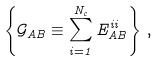<formula> <loc_0><loc_0><loc_500><loc_500>\left \{ \mathcal { G } _ { A B } \equiv \sum _ { i = 1 } ^ { N _ { c } } E _ { A B } ^ { i i } \right \} \, ,</formula> 